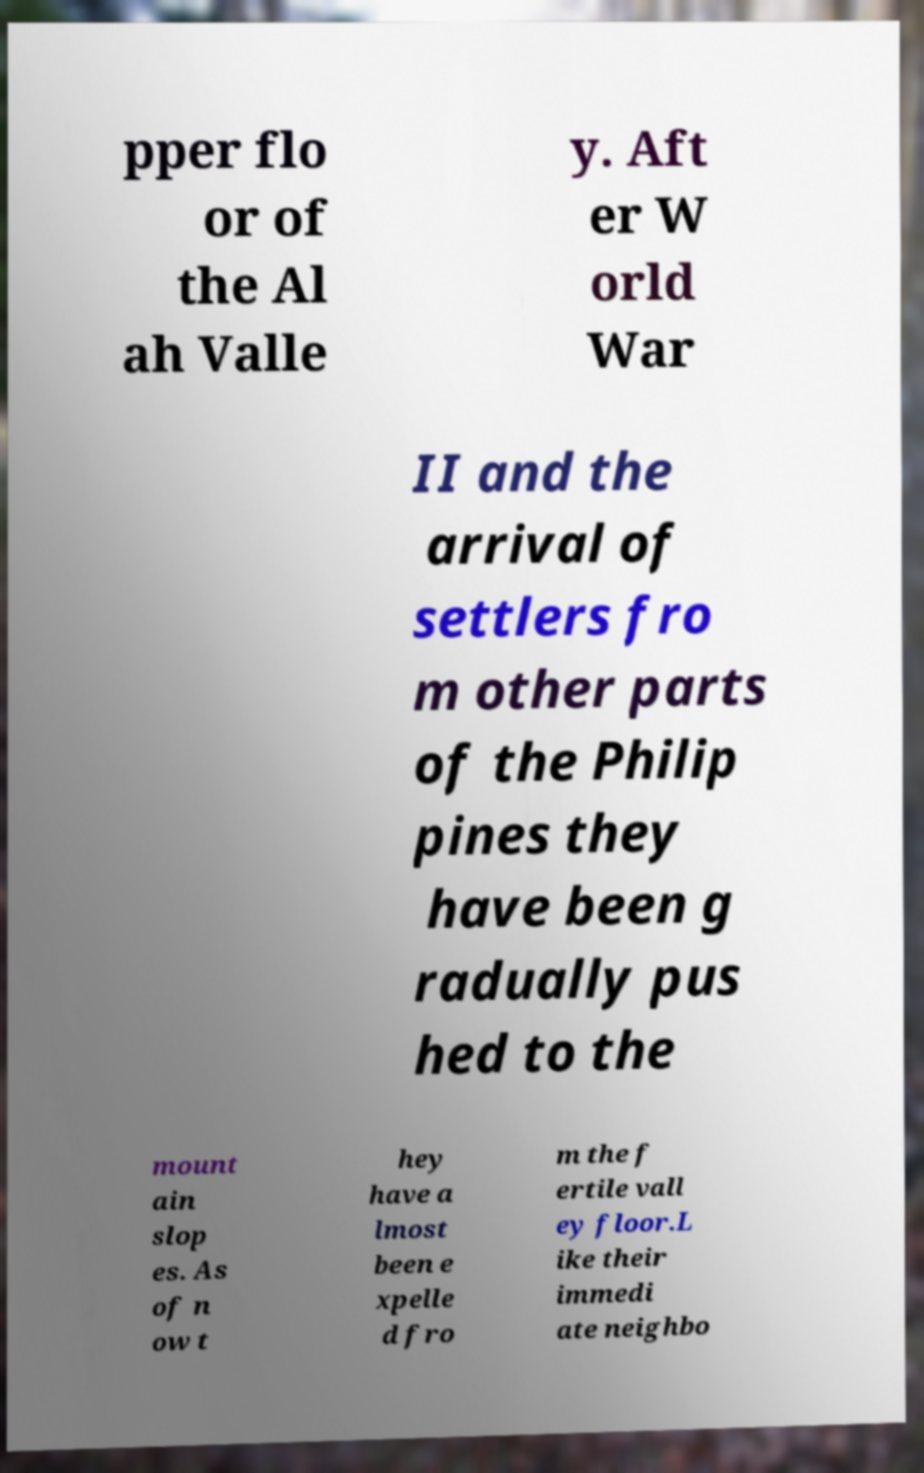Can you accurately transcribe the text from the provided image for me? pper flo or of the Al ah Valle y. Aft er W orld War II and the arrival of settlers fro m other parts of the Philip pines they have been g radually pus hed to the mount ain slop es. As of n ow t hey have a lmost been e xpelle d fro m the f ertile vall ey floor.L ike their immedi ate neighbo 